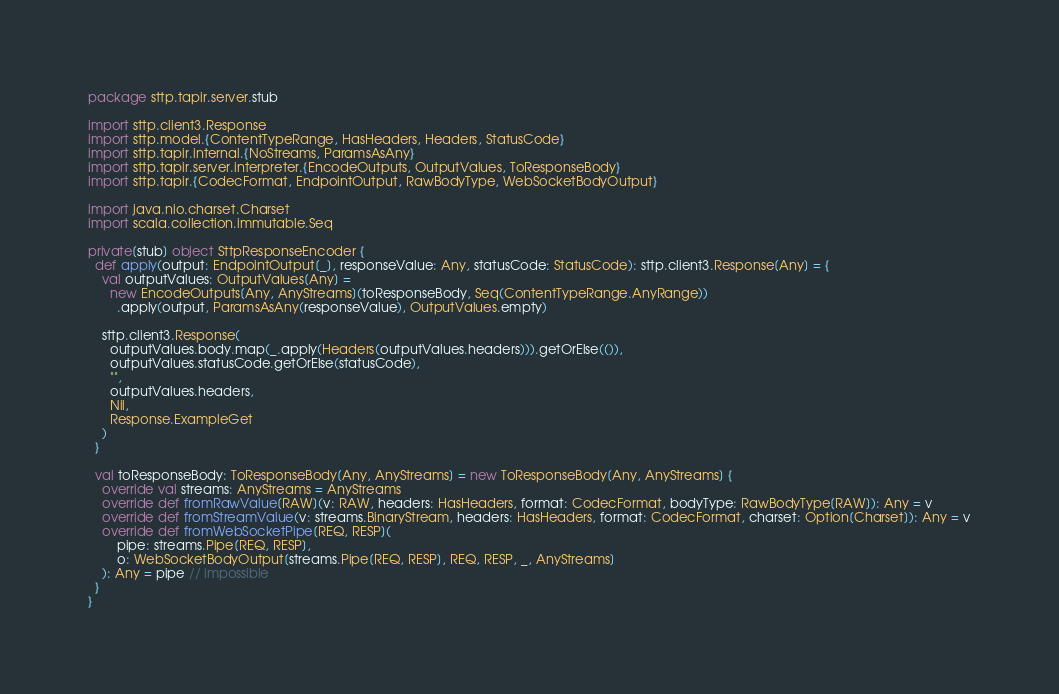<code> <loc_0><loc_0><loc_500><loc_500><_Scala_>package sttp.tapir.server.stub

import sttp.client3.Response
import sttp.model.{ContentTypeRange, HasHeaders, Headers, StatusCode}
import sttp.tapir.internal.{NoStreams, ParamsAsAny}
import sttp.tapir.server.interpreter.{EncodeOutputs, OutputValues, ToResponseBody}
import sttp.tapir.{CodecFormat, EndpointOutput, RawBodyType, WebSocketBodyOutput}

import java.nio.charset.Charset
import scala.collection.immutable.Seq

private[stub] object SttpResponseEncoder {
  def apply(output: EndpointOutput[_], responseValue: Any, statusCode: StatusCode): sttp.client3.Response[Any] = {
    val outputValues: OutputValues[Any] =
      new EncodeOutputs[Any, AnyStreams](toResponseBody, Seq(ContentTypeRange.AnyRange))
        .apply(output, ParamsAsAny(responseValue), OutputValues.empty)

    sttp.client3.Response(
      outputValues.body.map(_.apply(Headers(outputValues.headers))).getOrElse(()),
      outputValues.statusCode.getOrElse(statusCode),
      "",
      outputValues.headers,
      Nil,
      Response.ExampleGet
    )
  }

  val toResponseBody: ToResponseBody[Any, AnyStreams] = new ToResponseBody[Any, AnyStreams] {
    override val streams: AnyStreams = AnyStreams
    override def fromRawValue[RAW](v: RAW, headers: HasHeaders, format: CodecFormat, bodyType: RawBodyType[RAW]): Any = v
    override def fromStreamValue(v: streams.BinaryStream, headers: HasHeaders, format: CodecFormat, charset: Option[Charset]): Any = v
    override def fromWebSocketPipe[REQ, RESP](
        pipe: streams.Pipe[REQ, RESP],
        o: WebSocketBodyOutput[streams.Pipe[REQ, RESP], REQ, RESP, _, AnyStreams]
    ): Any = pipe // impossible
  }
}
</code> 